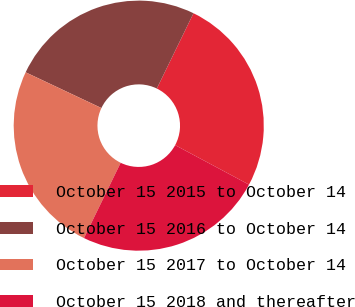<chart> <loc_0><loc_0><loc_500><loc_500><pie_chart><fcel>October 15 2015 to October 14<fcel>October 15 2016 to October 14<fcel>October 15 2017 to October 14<fcel>October 15 2018 and thereafter<nl><fcel>25.6%<fcel>25.2%<fcel>24.8%<fcel>24.4%<nl></chart> 